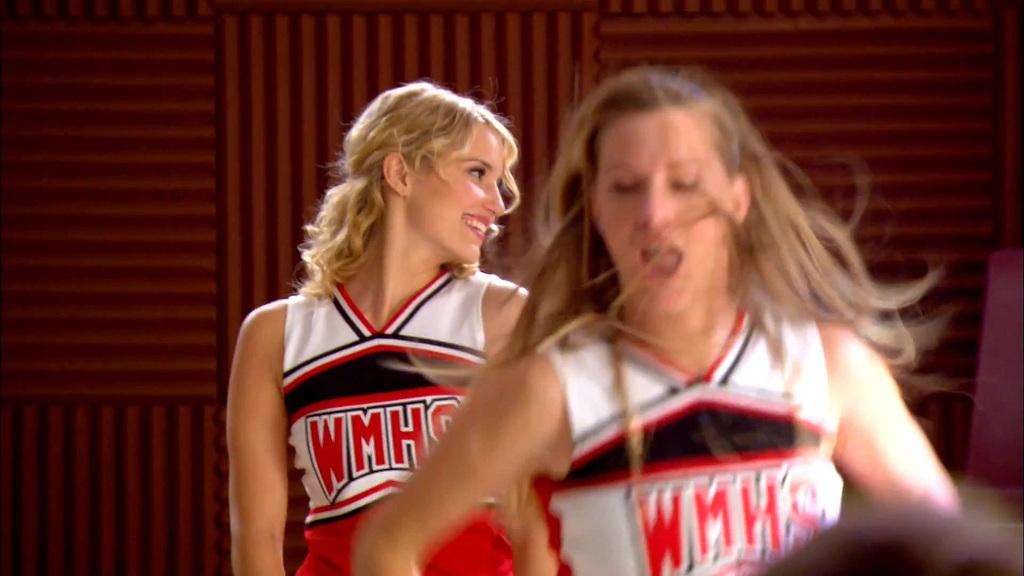Provide a one-sentence caption for the provided image. Two cheerleaders are shown in red, white, and black uniforms from WMHS. 